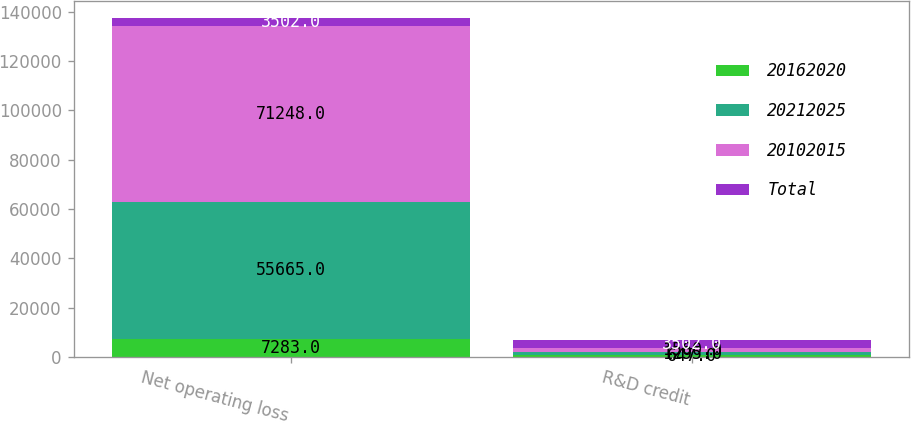Convert chart to OTSL. <chart><loc_0><loc_0><loc_500><loc_500><stacked_bar_chart><ecel><fcel>Net operating loss<fcel>R&D credit<nl><fcel>20162020<fcel>7283<fcel>647<nl><fcel>20212025<fcel>55665<fcel>1295<nl><fcel>20102015<fcel>71248<fcel>1560<nl><fcel>Total<fcel>3502<fcel>3502<nl></chart> 